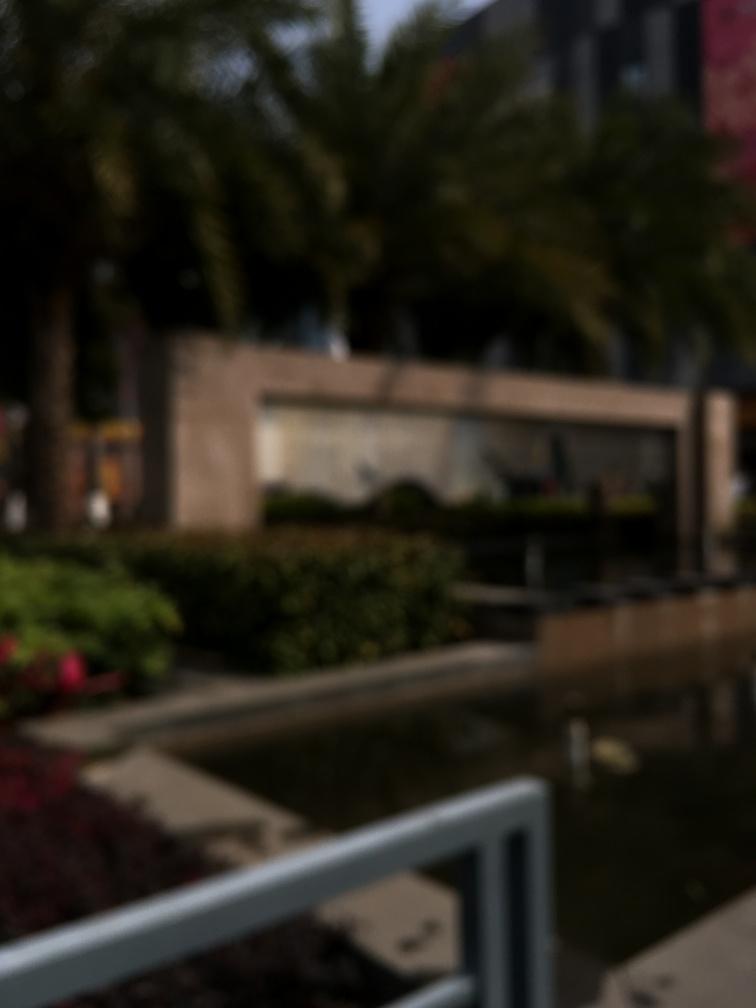What could be the reason for this image's poor quality? The poor quality could be due to several factors such as camera movement during the shot, an out-of-focus lens, a low-resolution camera, or it might have been taken with an artistic intent to convey a certain mood or style. Could the weather have played a part in this effect? It's possible that weather conditions such as fog, rain, or mist contributed to the blurriness, but this effect is more often attributed to camera settings or movement rather than environmental factors. 